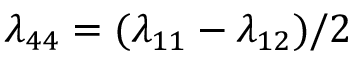Convert formula to latex. <formula><loc_0><loc_0><loc_500><loc_500>\lambda _ { 4 4 } = ( \lambda _ { 1 1 } - \lambda _ { 1 2 } ) / 2</formula> 